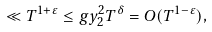Convert formula to latex. <formula><loc_0><loc_0><loc_500><loc_500>\ll T ^ { 1 + \varepsilon } \leq g { y _ { 2 } ^ { 2 } } { T } ^ { \delta } = O ( T ^ { 1 - \varepsilon } ) ,</formula> 